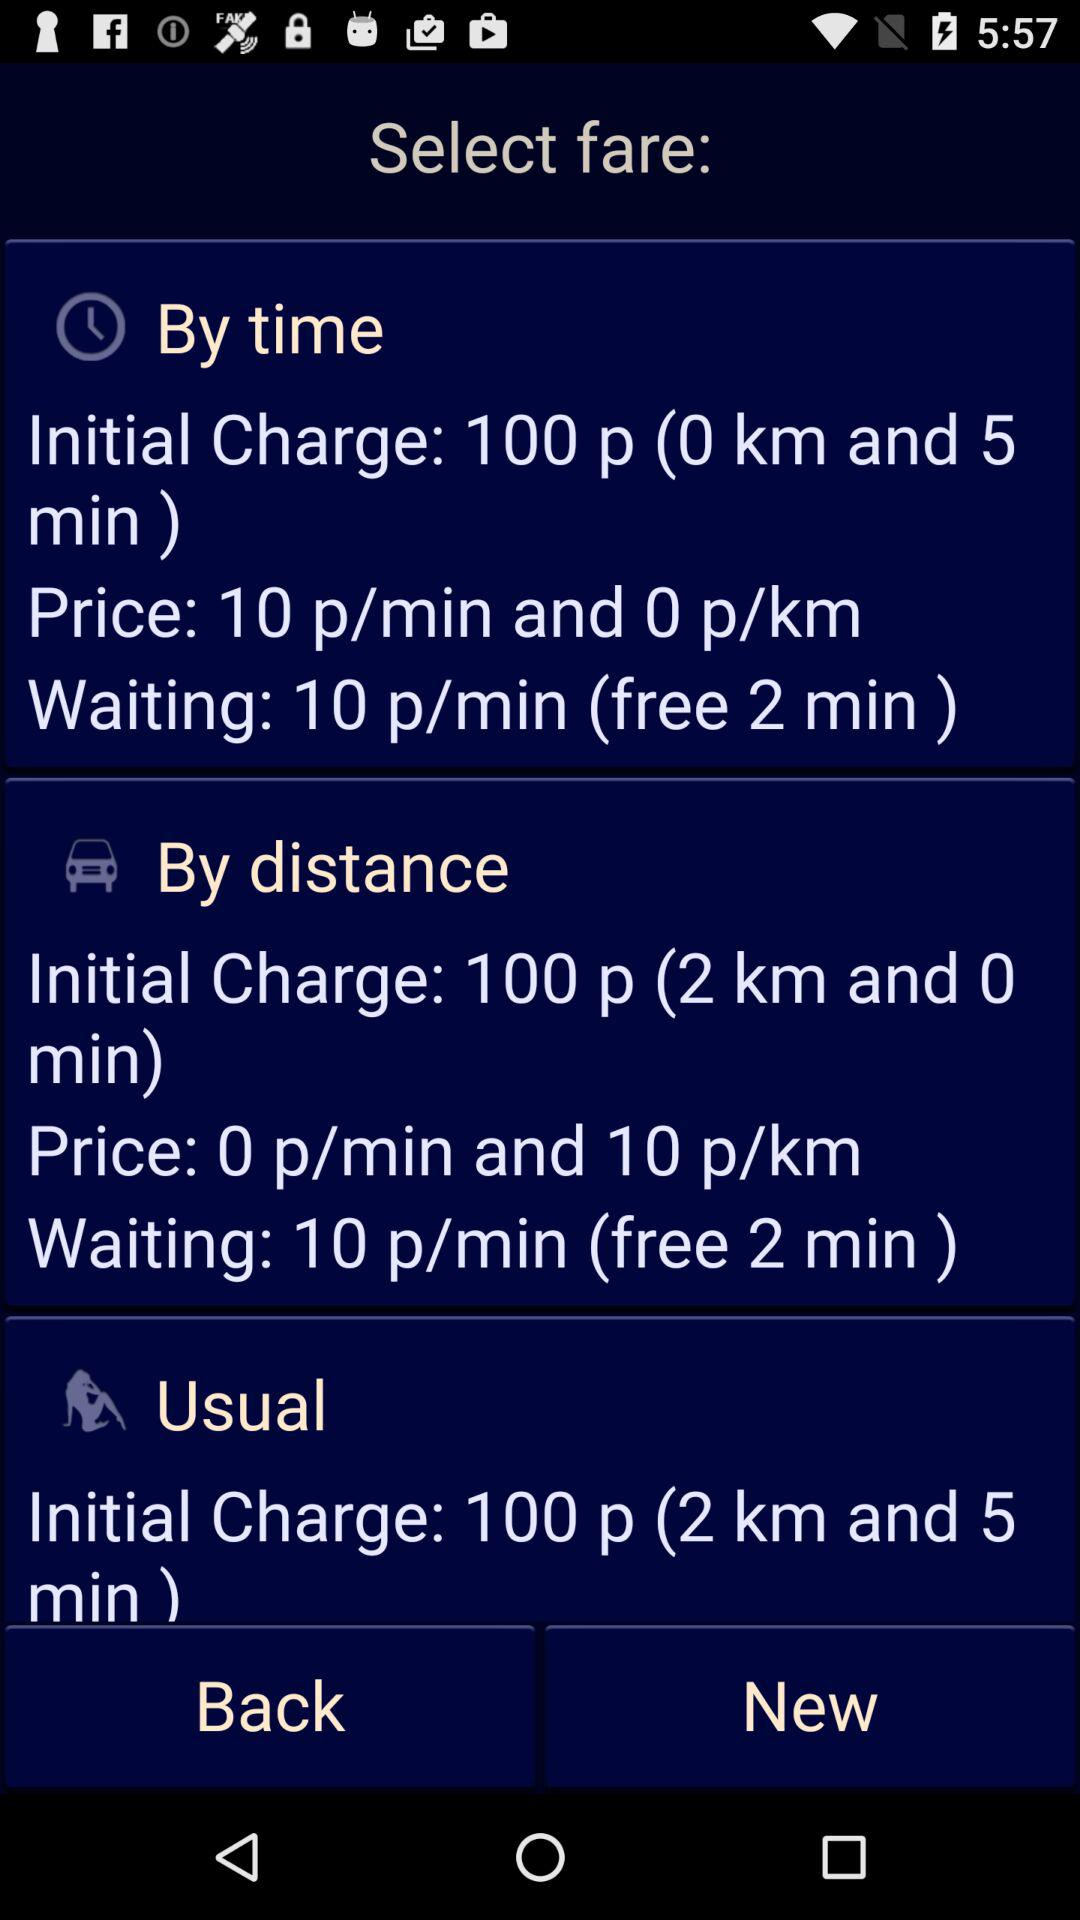Which are the different options to select the fare? The different options to select the fare are "By time", "By distance" and "Usual". 